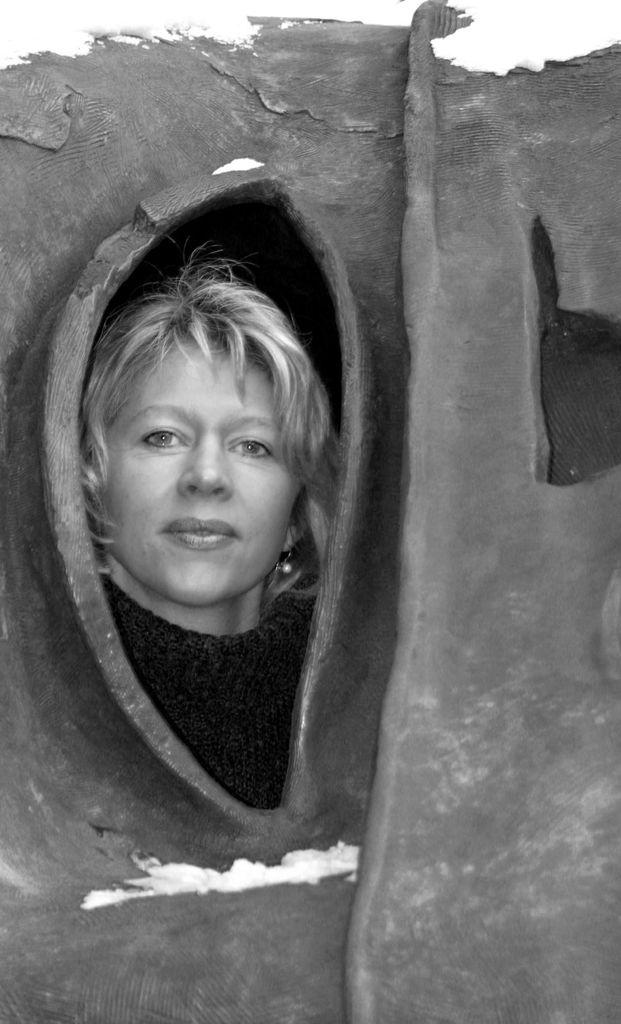What can be seen in the image? There is a wall in the image, and there is a hole in the wall. What is visible through the hole in the wall? A person's face is visible through the hole. How does the person's face react to the fly in the image? There is no fly present in the image, so it is not possible to determine how the person's face might react to a fly. 